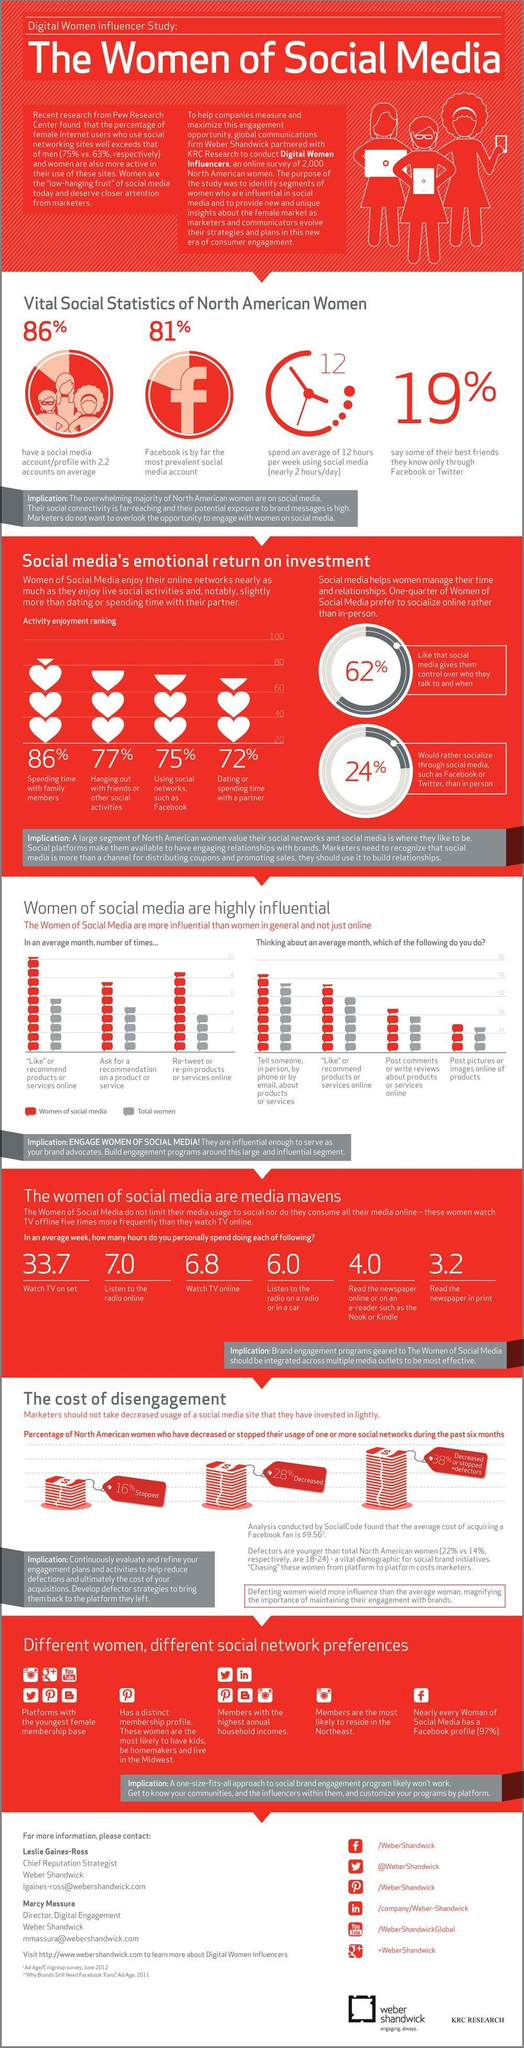What percentage of women are not dating or spending time with a partner?
Answer the question with a short phrase. 28% In an average week, how many hours women spend time watching TV on set? 33.7 In an average week, how many hours women spend time watching TV online? 6.8 In an average week, how many hours women spend time listening to the radio on the radio or in a car? 6.0 What percentage of North American Women have no social media account with 2.2 accounts on average? 14% In an average week, how many hours women spend time reading the newspaper online? 4.0 What percentage of women are not hanging out with friends or other social activities? 23% What percentage of women are not using social networks such as Facebook? 25% In an average week, how many hours women spend time reading the newspaper in print? 3.2 In an average week, how many hours women spend time listening to the radio online? 7.0 